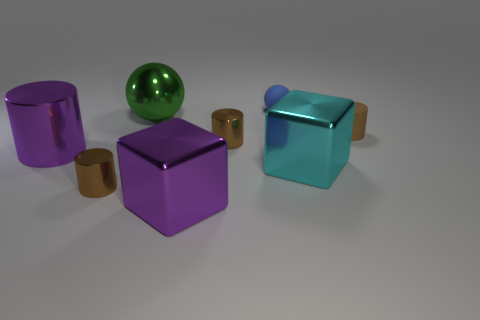What number of things are either spheres or blue spheres?
Offer a terse response. 2. There is a sphere in front of the matte sphere; does it have the same size as the brown cylinder to the left of the green sphere?
Your answer should be compact. No. What number of other things are there of the same material as the green ball
Ensure brevity in your answer.  5. Are there more big green things left of the large green metallic thing than large cylinders in front of the blue matte sphere?
Offer a very short reply. No. There is a small thing to the right of the large cyan object; what material is it?
Keep it short and to the point. Rubber. Is the tiny blue object the same shape as the brown rubber object?
Offer a very short reply. No. Is there anything else that is the same color as the rubber cylinder?
Ensure brevity in your answer.  Yes. What color is the other thing that is the same shape as the cyan shiny object?
Your response must be concise. Purple. Is the number of metal objects that are to the left of the big green object greater than the number of large cyan shiny objects?
Provide a succinct answer. Yes. There is a big metallic block that is to the left of the blue ball; what color is it?
Ensure brevity in your answer.  Purple. 